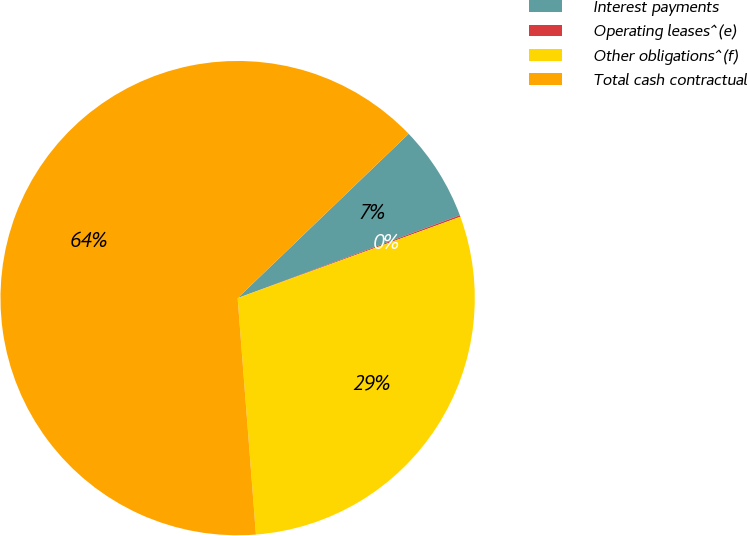Convert chart to OTSL. <chart><loc_0><loc_0><loc_500><loc_500><pie_chart><fcel>Interest payments<fcel>Operating leases^(e)<fcel>Other obligations^(f)<fcel>Total cash contractual<nl><fcel>6.5%<fcel>0.11%<fcel>29.34%<fcel>64.04%<nl></chart> 